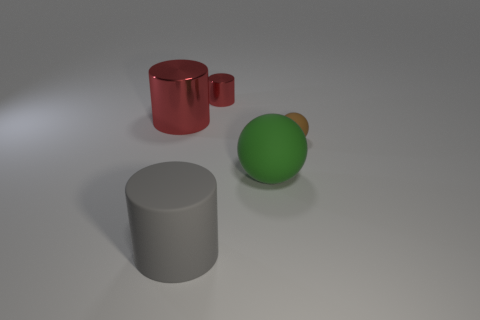How many other things are the same material as the big green ball?
Make the answer very short. 2. There is a tiny thing that is in front of the red metallic thing that is in front of the shiny cylinder to the right of the gray cylinder; what shape is it?
Ensure brevity in your answer.  Sphere. Is the number of small rubber things right of the tiny brown rubber ball less than the number of large green matte things on the left side of the big green object?
Offer a very short reply. No. Is there a small cylinder that has the same color as the big metal cylinder?
Your answer should be very brief. Yes. Does the small red cylinder have the same material as the cylinder that is in front of the big red object?
Your answer should be compact. No. There is a red cylinder in front of the tiny red metal cylinder; are there any red objects that are right of it?
Your answer should be very brief. Yes. There is a object that is both behind the brown rubber ball and in front of the tiny red object; what is its color?
Keep it short and to the point. Red. How big is the brown sphere?
Your response must be concise. Small. How many shiny cylinders are the same size as the brown matte sphere?
Keep it short and to the point. 1. Is the material of the large thing on the right side of the small red cylinder the same as the ball that is on the right side of the green rubber sphere?
Ensure brevity in your answer.  Yes. 